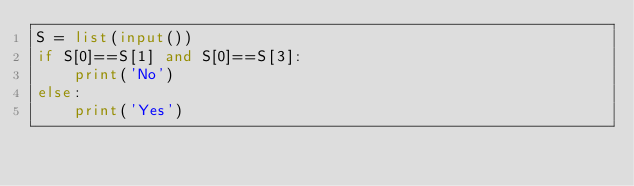Convert code to text. <code><loc_0><loc_0><loc_500><loc_500><_Python_>S = list(input())
if S[0]==S[1] and S[0]==S[3]:
    print('No')
else:
    print('Yes')</code> 